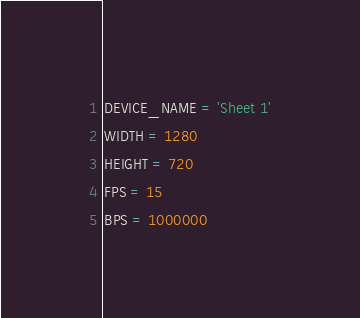<code> <loc_0><loc_0><loc_500><loc_500><_Python_>DEVICE_NAME = 'Sheet 1'
WIDTH = 1280
HEIGHT = 720
FPS = 15
BPS = 1000000
</code> 